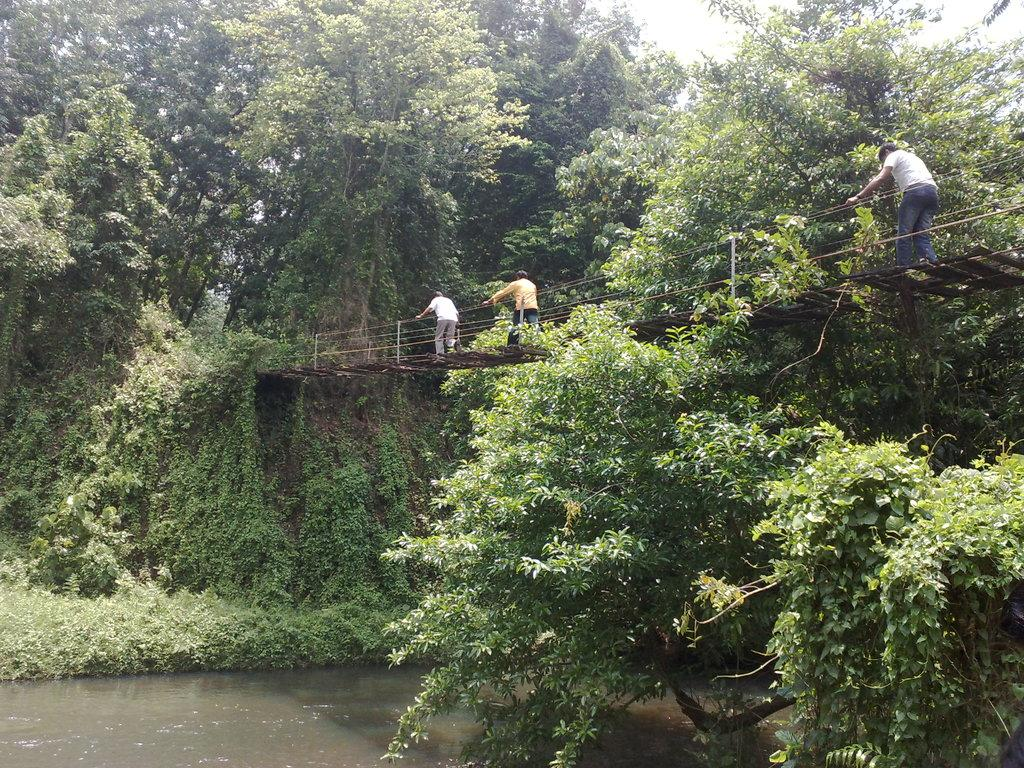What structure can be seen in the image? There is a bridge in the image. What are the people in the image doing? The people are walking on the bridge. What type of vegetation is visible in the image? There are trees visible in the image. What is located at the bottom of the image? There is water visible at the bottom of the image. What shape is the pet that is visible in the image? There is no pet present in the image. What tool is being used by the people walking on the bridge in the image? There is no tool visible in the image; the people are simply walking on the bridge. 